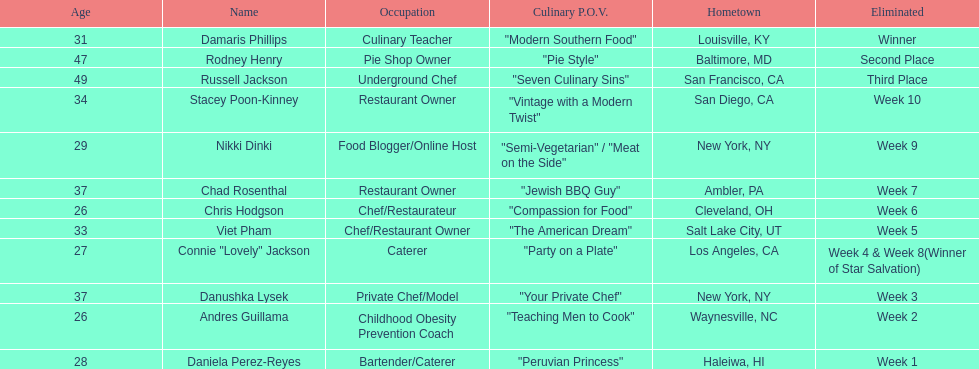For which contestant was their culinary approach elaborated more than "vintage with a modern twist"? Nikki Dinki. Help me parse the entirety of this table. {'header': ['Age', 'Name', 'Occupation', 'Culinary P.O.V.', 'Hometown', 'Eliminated'], 'rows': [['31', 'Damaris Phillips', 'Culinary Teacher', '"Modern Southern Food"', 'Louisville, KY', 'Winner'], ['47', 'Rodney Henry', 'Pie Shop Owner', '"Pie Style"', 'Baltimore, MD', 'Second Place'], ['49', 'Russell Jackson', 'Underground Chef', '"Seven Culinary Sins"', 'San Francisco, CA', 'Third Place'], ['34', 'Stacey Poon-Kinney', 'Restaurant Owner', '"Vintage with a Modern Twist"', 'San Diego, CA', 'Week 10'], ['29', 'Nikki Dinki', 'Food Blogger/Online Host', '"Semi-Vegetarian" / "Meat on the Side"', 'New York, NY', 'Week 9'], ['37', 'Chad Rosenthal', 'Restaurant Owner', '"Jewish BBQ Guy"', 'Ambler, PA', 'Week 7'], ['26', 'Chris Hodgson', 'Chef/Restaurateur', '"Compassion for Food"', 'Cleveland, OH', 'Week 6'], ['33', 'Viet Pham', 'Chef/Restaurant Owner', '"The American Dream"', 'Salt Lake City, UT', 'Week 5'], ['27', 'Connie "Lovely" Jackson', 'Caterer', '"Party on a Plate"', 'Los Angeles, CA', 'Week 4 & Week 8(Winner of Star Salvation)'], ['37', 'Danushka Lysek', 'Private Chef/Model', '"Your Private Chef"', 'New York, NY', 'Week 3'], ['26', 'Andres Guillama', 'Childhood Obesity Prevention Coach', '"Teaching Men to Cook"', 'Waynesville, NC', 'Week 2'], ['28', 'Daniela Perez-Reyes', 'Bartender/Caterer', '"Peruvian Princess"', 'Haleiwa, HI', 'Week 1']]} 